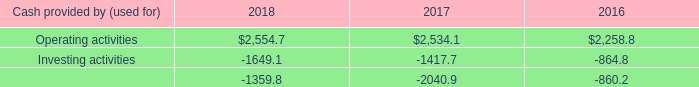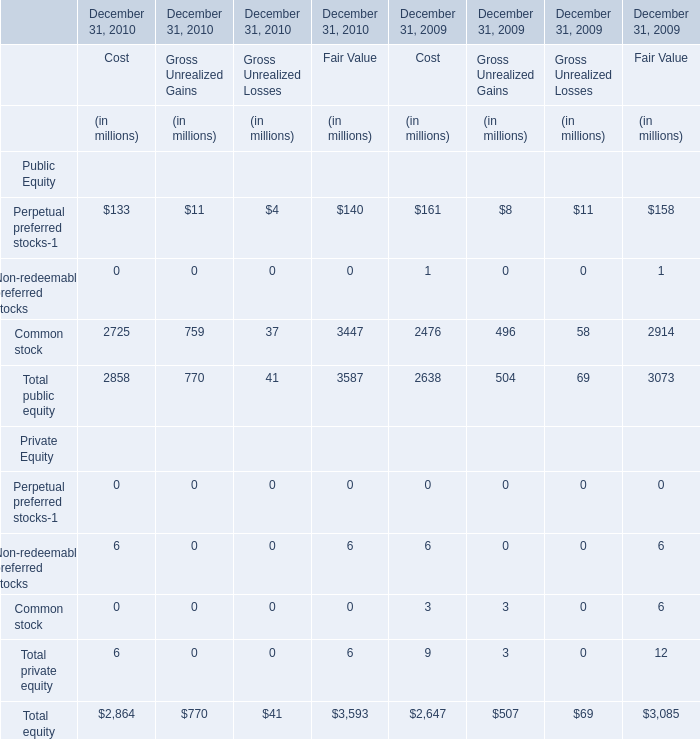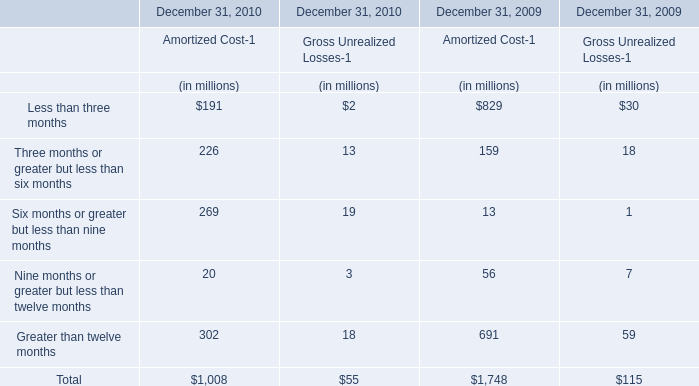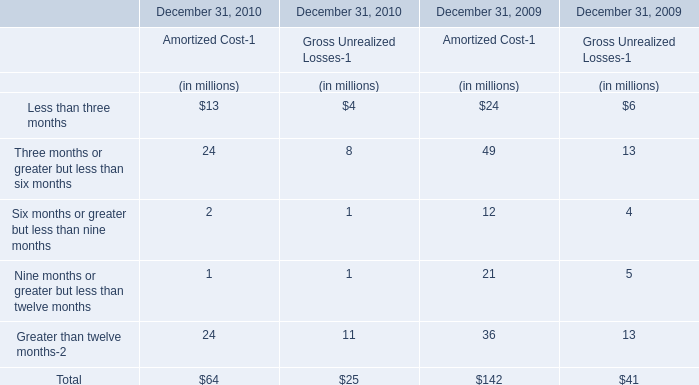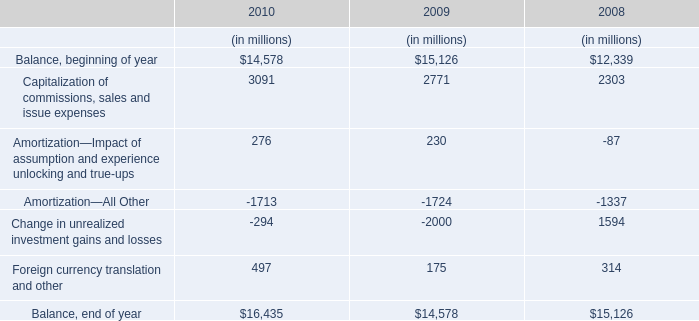what is the final amount of cash and cash equivalents in 2016? 
Computations: ((2258.8 - 864.8) - 860.2)
Answer: 533.8. 